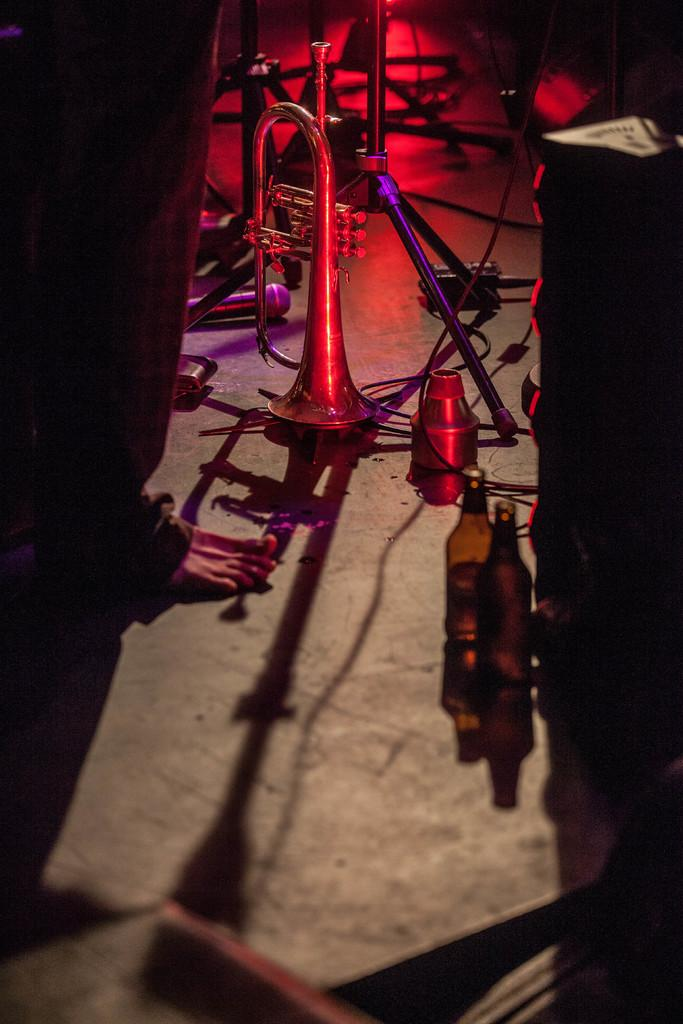What is the main subject in the image? There is a man standing in the image. What object is associated with the man in the image? There is a trumpet instrument in the image. What else can be seen on the floor in the image? There are two bottles placed on the floor in the image. Can you identify any equipment related to sound in the image? There appears to be a microphone stand in the image. What type of boot is the man wearing in the image? The image does not show the man wearing any boots; he is wearing shoes. What role does the man's father play in the image? The image does not show or mention the man's father, so it is impossible to determine his role. 